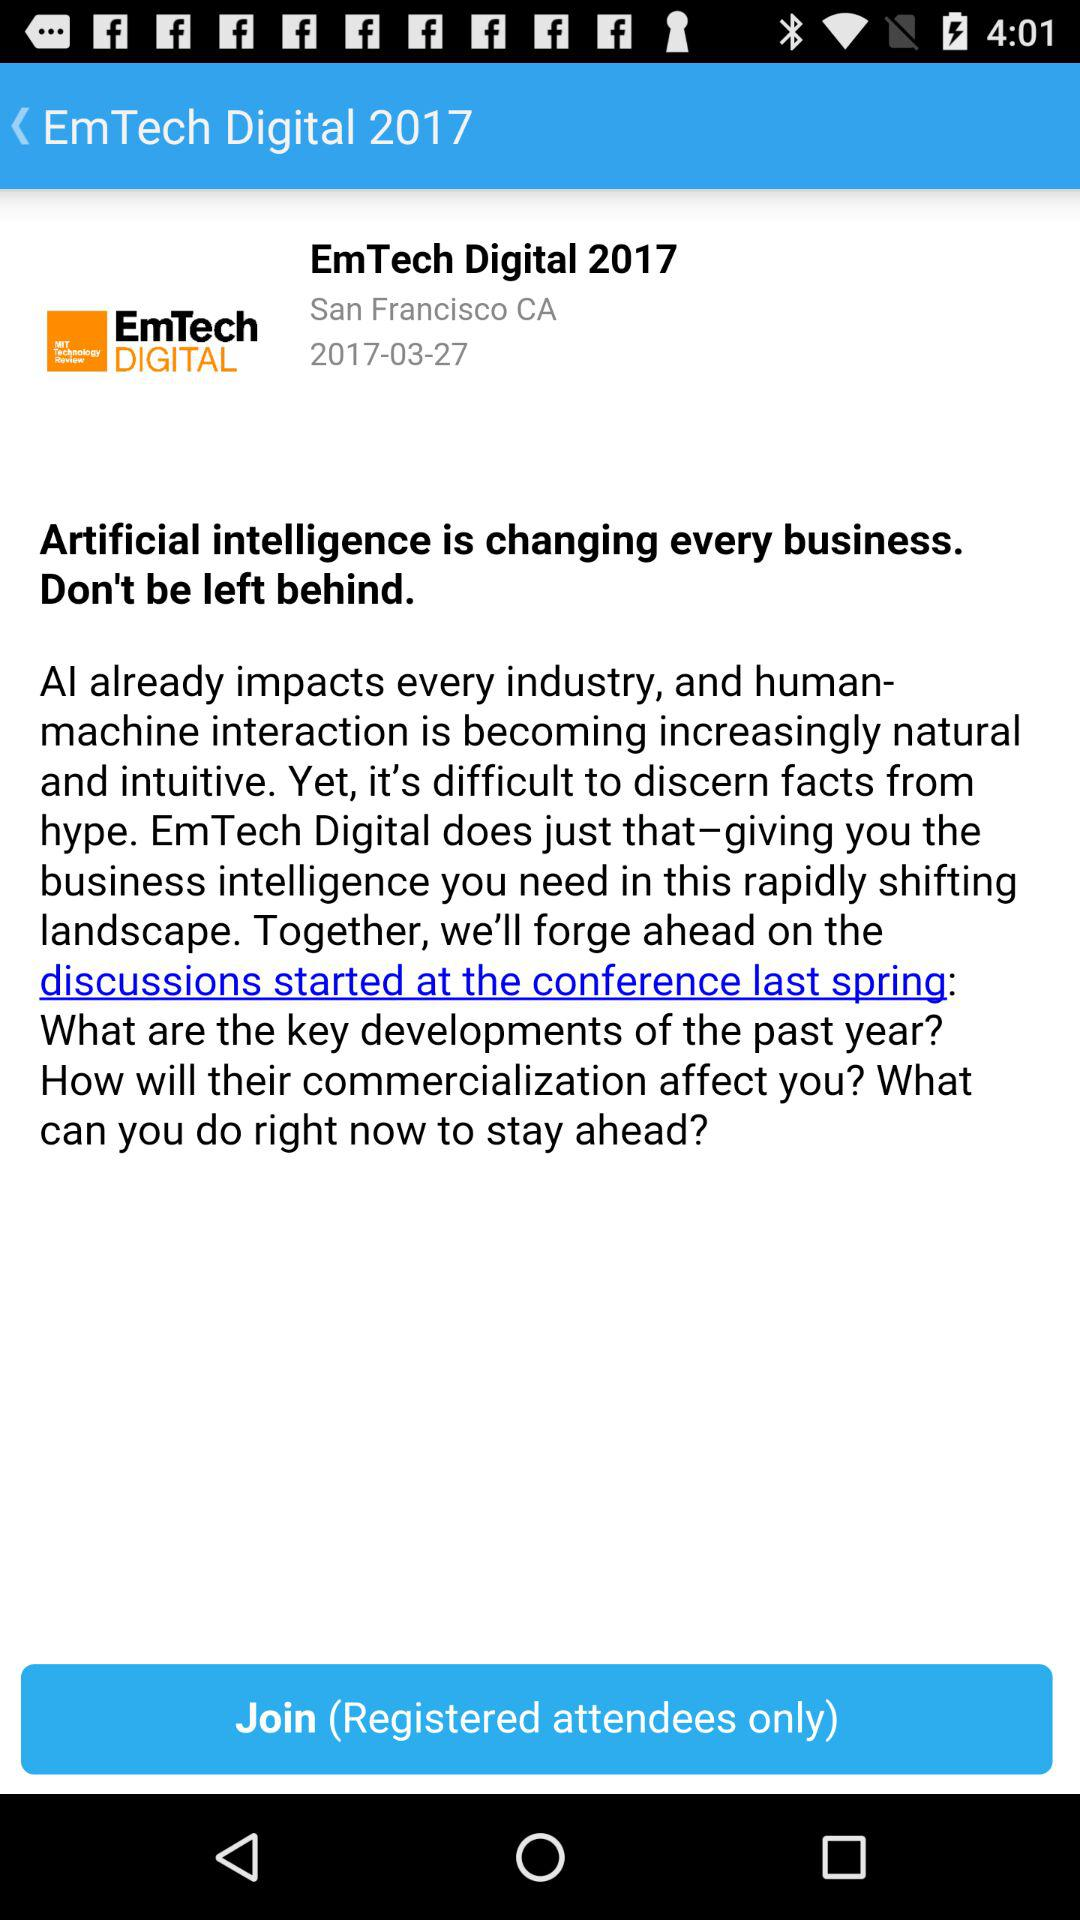What is the location of EmTech Digital 2017? The location of EmTech Digital 2017 is San Francisco, CA. 